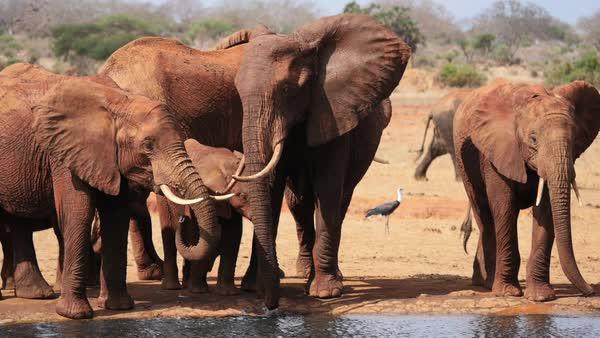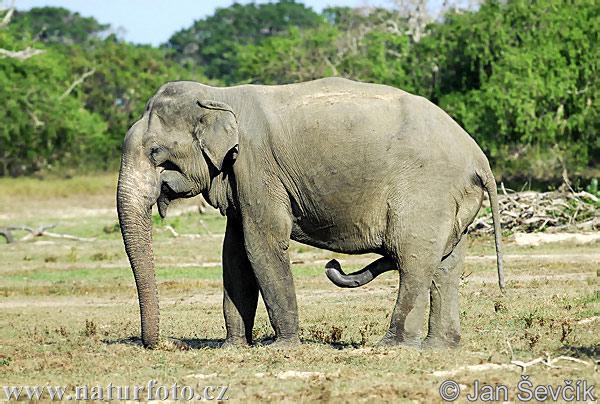The first image is the image on the left, the second image is the image on the right. Given the left and right images, does the statement "The photo on the right contains a single elephant." hold true? Answer yes or no. Yes. The first image is the image on the left, the second image is the image on the right. Analyze the images presented: Is the assertion "Multiple pairs of elephant tusks are visible." valid? Answer yes or no. Yes. 